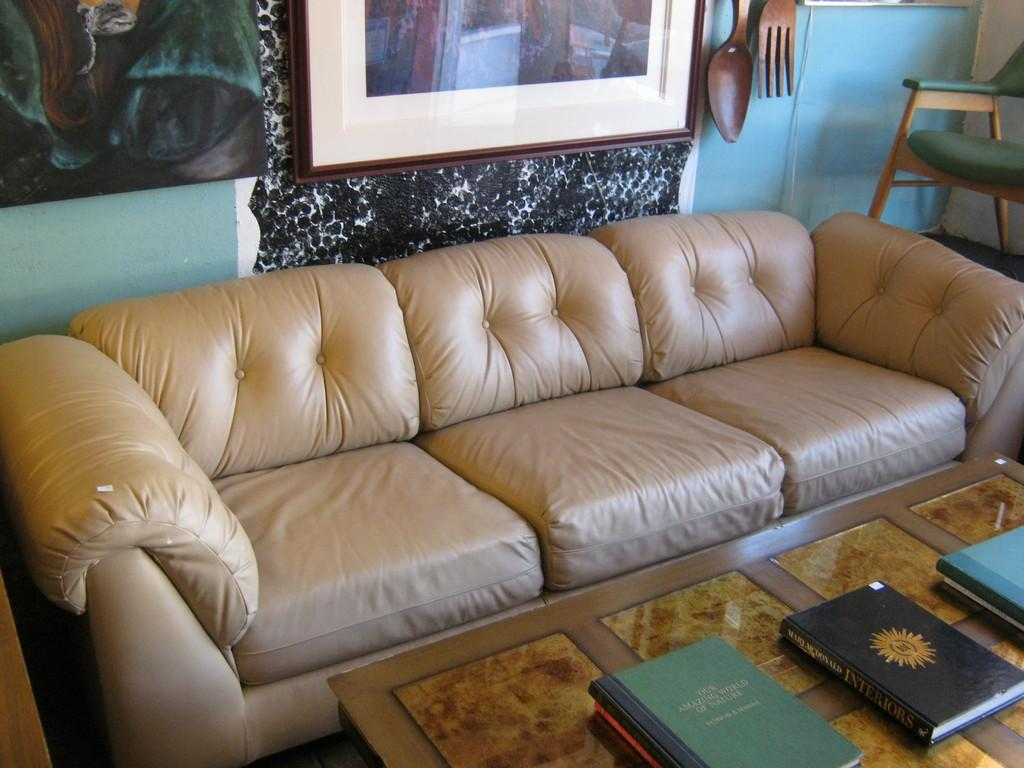What type of furniture is in the image? There is a sofa bed in the image. What items can be seen on the table in the image? There are books on a table in the image. What is hanging on the wall in the image? There is a photo frame on the wall in the image. How many ladybugs are crawling on the sofa bed in the image? There are no ladybugs present in the image. What type of wool is used to make the sofa bed in the image? The image does not provide information about the materials used to make the sofa bed. 